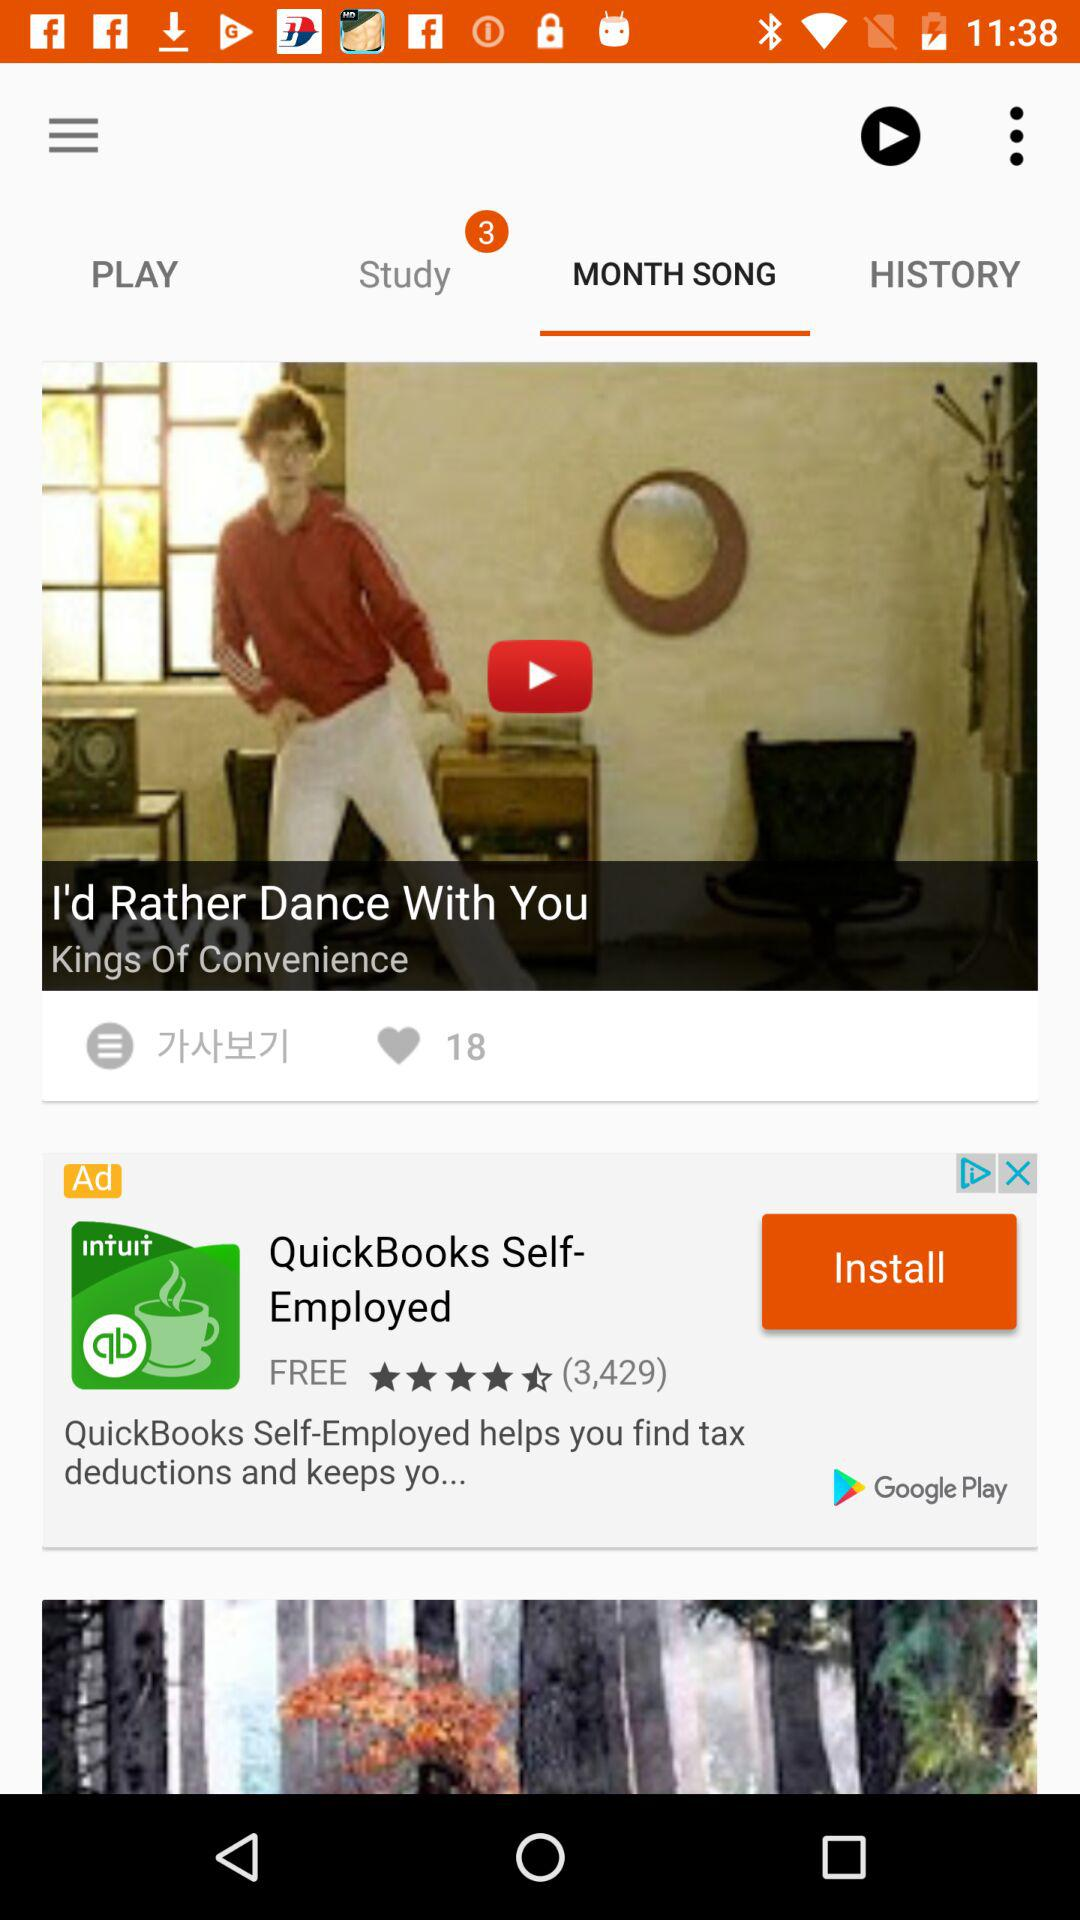What is the title of the video? The title of the video is "I'd Rather Dance With You". 